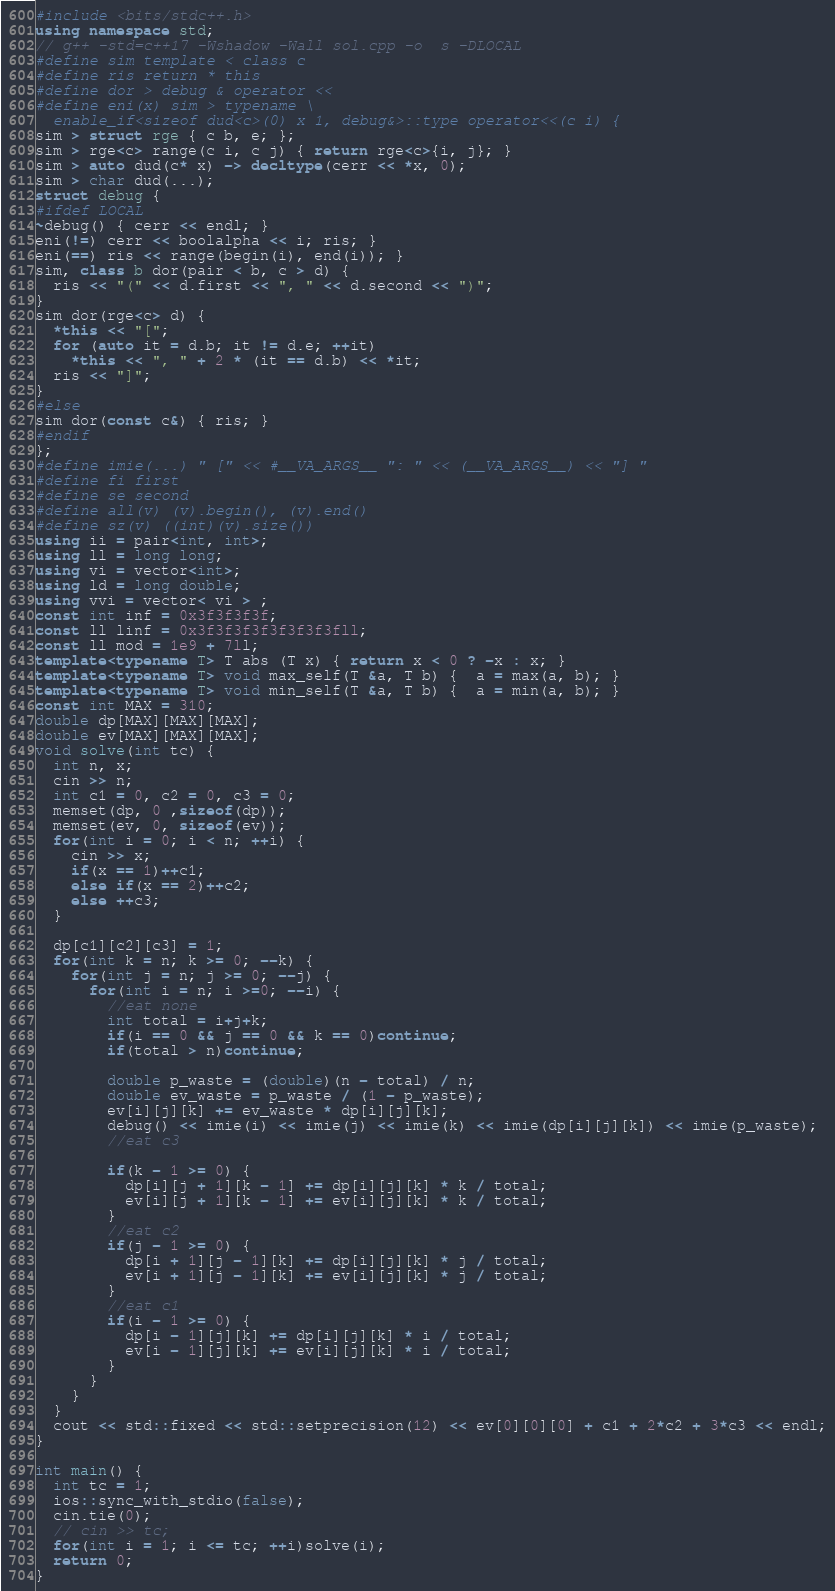<code> <loc_0><loc_0><loc_500><loc_500><_C++_>#include <bits/stdc++.h>
using namespace std;
// g++ -std=c++17 -Wshadow -Wall sol.cpp -o  s -DLOCAL
#define sim template < class c
#define ris return * this
#define dor > debug & operator <<
#define eni(x) sim > typename \
  enable_if<sizeof dud<c>(0) x 1, debug&>::type operator<<(c i) {
sim > struct rge { c b, e; };
sim > rge<c> range(c i, c j) { return rge<c>{i, j}; }
sim > auto dud(c* x) -> decltype(cerr << *x, 0);
sim > char dud(...);
struct debug {
#ifdef LOCAL
~debug() { cerr << endl; }
eni(!=) cerr << boolalpha << i; ris; }
eni(==) ris << range(begin(i), end(i)); }
sim, class b dor(pair < b, c > d) {
  ris << "(" << d.first << ", " << d.second << ")";
}
sim dor(rge<c> d) {
  *this << "[";
  for (auto it = d.b; it != d.e; ++it)
	*this << ", " + 2 * (it == d.b) << *it;
  ris << "]";
}
#else
sim dor(const c&) { ris; }
#endif
};
#define imie(...) " [" << #__VA_ARGS__ ": " << (__VA_ARGS__) << "] "
#define fi first
#define se second
#define all(v) (v).begin(), (v).end()
#define sz(v) ((int)(v).size())
using ii = pair<int, int>;
using ll = long long;
using vi = vector<int>;
using ld = long double;
using vvi = vector< vi > ;
const int inf = 0x3f3f3f3f;
const ll linf = 0x3f3f3f3f3f3f3f3fll;
const ll mod = 1e9 + 7ll;
template<typename T> T abs (T x) { return x < 0 ? -x : x; }
template<typename T> void max_self(T &a, T b) {  a = max(a, b); }
template<typename T> void min_self(T &a, T b) {  a = min(a, b); }
const int MAX = 310;
double dp[MAX][MAX][MAX];
double ev[MAX][MAX][MAX];
void solve(int tc) {
  int n, x;
  cin >> n;
  int c1 = 0, c2 = 0, c3 = 0;
  memset(dp, 0 ,sizeof(dp));
  memset(ev, 0, sizeof(ev));
  for(int i = 0; i < n; ++i) {
    cin >> x;
    if(x == 1)++c1;
    else if(x == 2)++c2;
    else ++c3;
  }

  dp[c1][c2][c3] = 1;
  for(int k = n; k >= 0; --k) {
    for(int j = n; j >= 0; --j) {
      for(int i = n; i >=0; --i) {
        //eat none
        int total = i+j+k;
        if(i == 0 && j == 0 && k == 0)continue;
        if(total > n)continue;

        double p_waste = (double)(n - total) / n;
        double ev_waste = p_waste / (1 - p_waste);
        ev[i][j][k] += ev_waste * dp[i][j][k];
        debug() << imie(i) << imie(j) << imie(k) << imie(dp[i][j][k]) << imie(p_waste);
        //eat c3
        
        if(k - 1 >= 0) {
          dp[i][j + 1][k - 1] += dp[i][j][k] * k / total;
          ev[i][j + 1][k - 1] += ev[i][j][k] * k / total;
        }
        //eat c2
        if(j - 1 >= 0) {
          dp[i + 1][j - 1][k] += dp[i][j][k] * j / total;
          ev[i + 1][j - 1][k] += ev[i][j][k] * j / total;
        }
        //eat c1
        if(i - 1 >= 0) {
          dp[i - 1][j][k] += dp[i][j][k] * i / total;
          ev[i - 1][j][k] += ev[i][j][k] * i / total;
        }
      }
    }
  }
  cout << std::fixed << std::setprecision(12) << ev[0][0][0] + c1 + 2*c2 + 3*c3 << endl;
}
 
int main() {
  int tc = 1;
  ios::sync_with_stdio(false);
  cin.tie(0);
  // cin >> tc;
  for(int i = 1; i <= tc; ++i)solve(i);
  return 0;
}</code> 